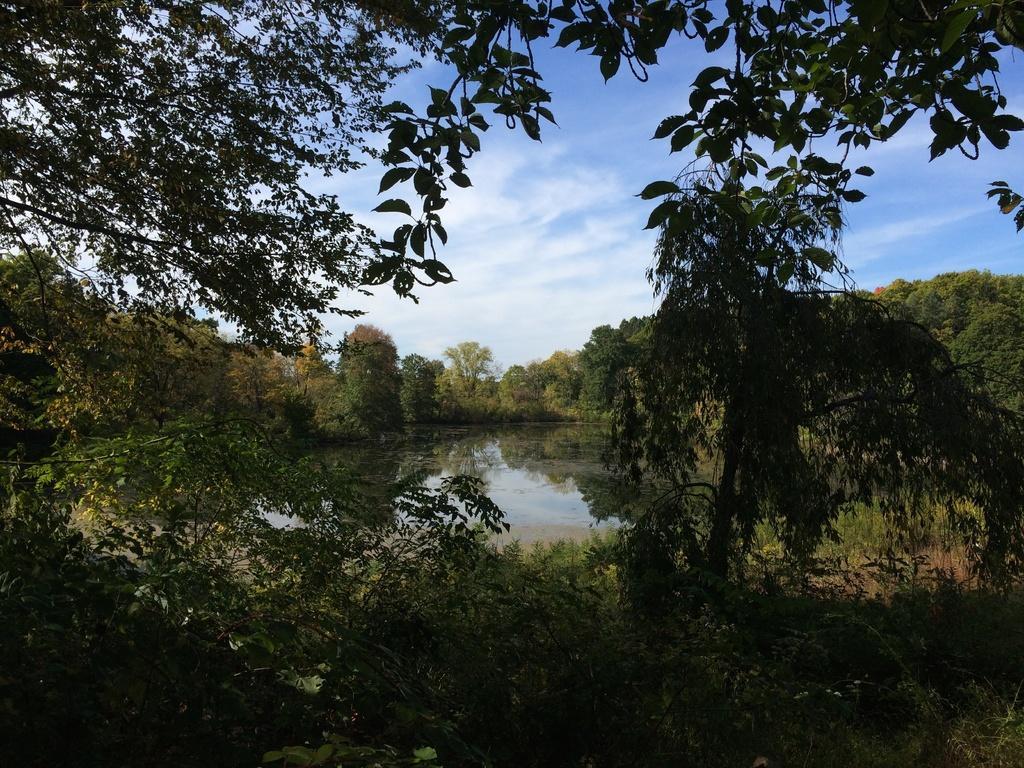How would you summarize this image in a sentence or two? In this image I can see trees in green color, water, and sky in blue and white color. 